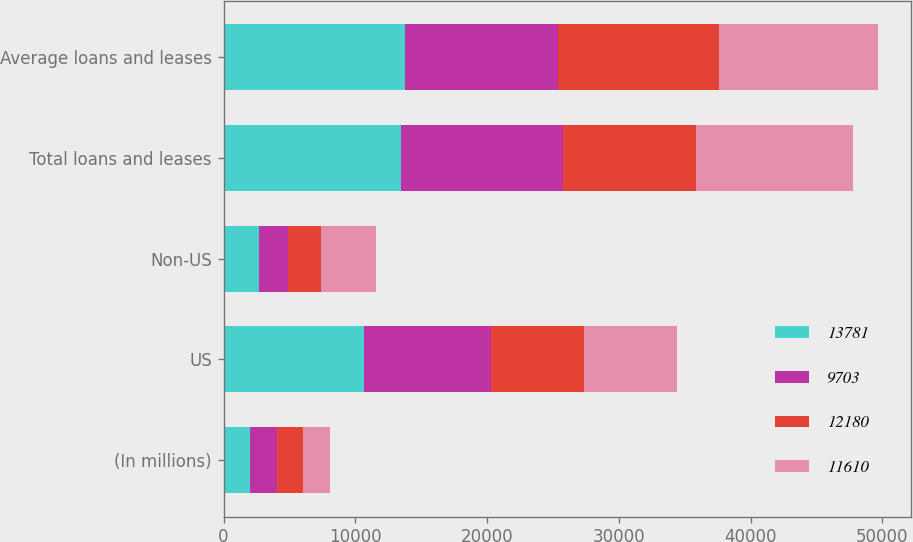Convert chart to OTSL. <chart><loc_0><loc_0><loc_500><loc_500><stacked_bar_chart><ecel><fcel>(In millions)<fcel>US<fcel>Non-US<fcel>Total loans and leases<fcel>Average loans and leases<nl><fcel>13781<fcel>2013<fcel>10623<fcel>2654<fcel>13486<fcel>13781<nl><fcel>9703<fcel>2012<fcel>9645<fcel>2251<fcel>12307<fcel>11610<nl><fcel>12180<fcel>2011<fcel>7115<fcel>2478<fcel>10053<fcel>12180<nl><fcel>11610<fcel>2010<fcel>7001<fcel>4192<fcel>11957<fcel>12094<nl></chart> 